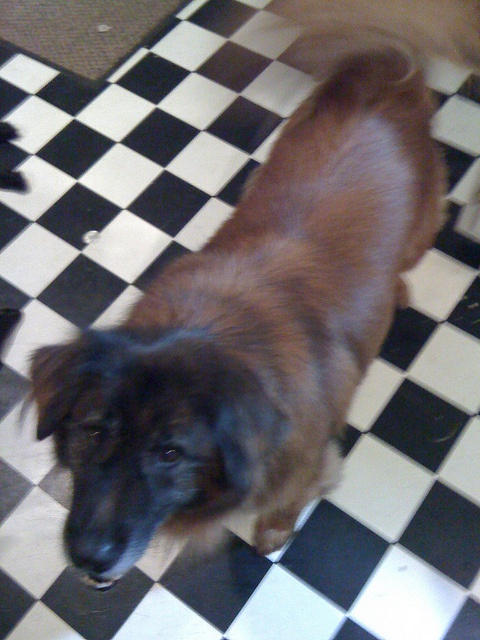Describe the objects in this image and their specific colors. I can see a dog in gray, black, and maroon tones in this image. 